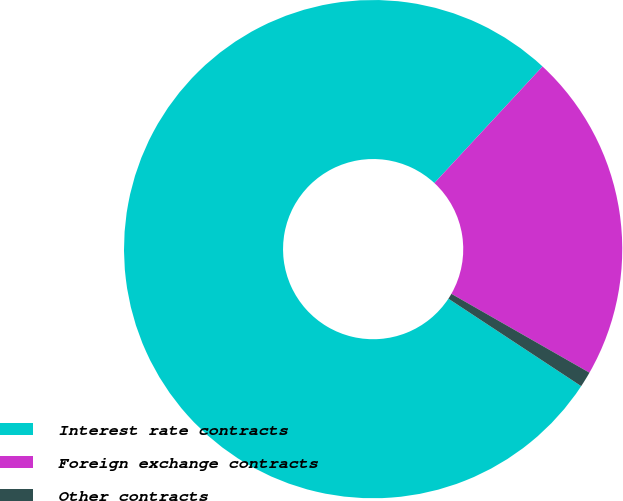Convert chart to OTSL. <chart><loc_0><loc_0><loc_500><loc_500><pie_chart><fcel>Interest rate contracts<fcel>Foreign exchange contracts<fcel>Other contracts<nl><fcel>77.63%<fcel>21.36%<fcel>1.01%<nl></chart> 